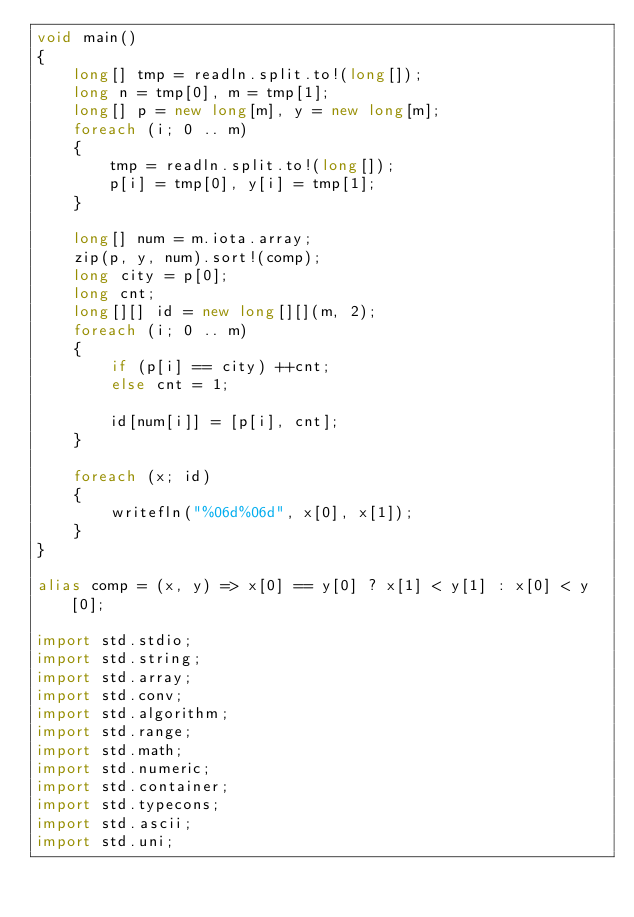<code> <loc_0><loc_0><loc_500><loc_500><_D_>void main()
{
    long[] tmp = readln.split.to!(long[]);
    long n = tmp[0], m = tmp[1];
    long[] p = new long[m], y = new long[m];
    foreach (i; 0 .. m)
    {
        tmp = readln.split.to!(long[]);
        p[i] = tmp[0], y[i] = tmp[1];
    }

    long[] num = m.iota.array;
    zip(p, y, num).sort!(comp);
    long city = p[0];
    long cnt;
    long[][] id = new long[][](m, 2);
    foreach (i; 0 .. m)
    {
        if (p[i] == city) ++cnt;
        else cnt = 1;

        id[num[i]] = [p[i], cnt];
    }

    foreach (x; id)
    {
        writefln("%06d%06d", x[0], x[1]);
    }
}

alias comp = (x, y) => x[0] == y[0] ? x[1] < y[1] : x[0] < y[0];

import std.stdio;
import std.string;
import std.array;
import std.conv;
import std.algorithm;
import std.range;
import std.math;
import std.numeric;
import std.container;
import std.typecons;
import std.ascii;
import std.uni;</code> 